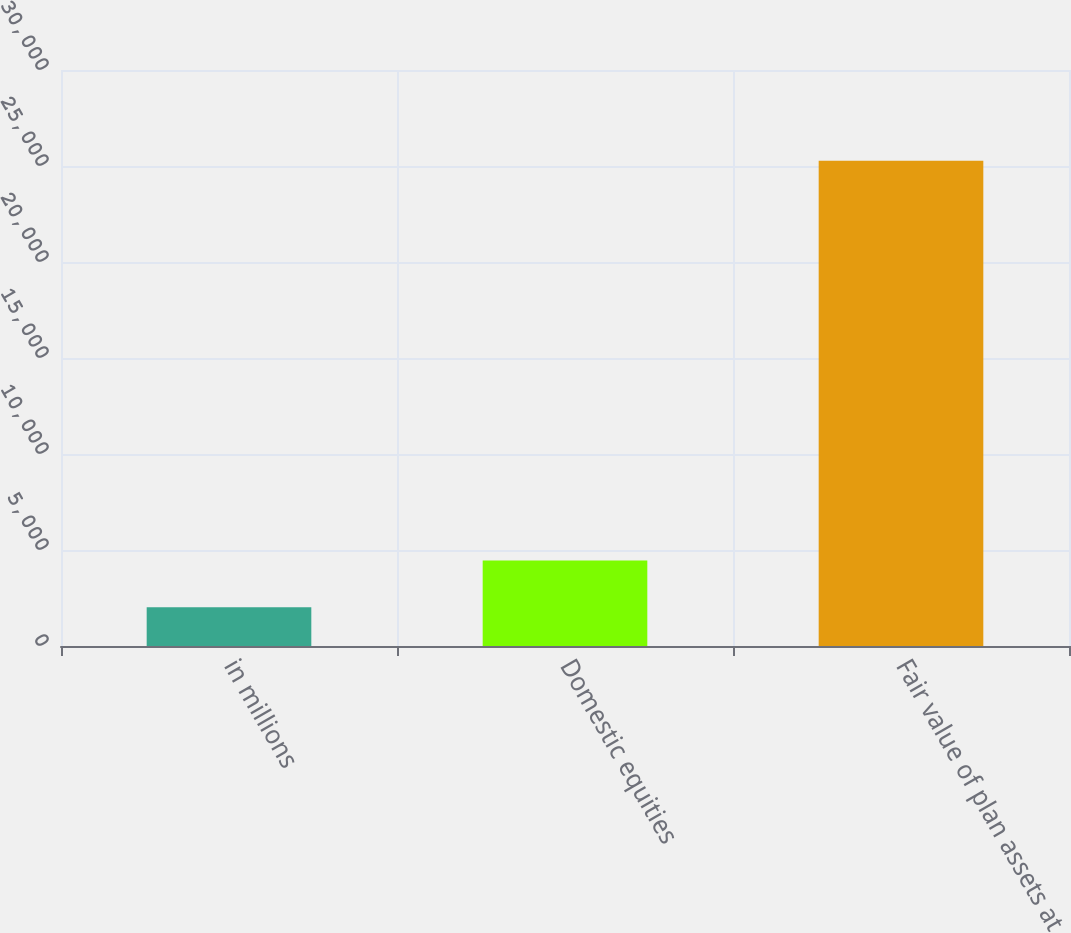<chart> <loc_0><loc_0><loc_500><loc_500><bar_chart><fcel>in millions<fcel>Domestic equities<fcel>Fair value of plan assets at<nl><fcel>2013<fcel>4452<fcel>25273<nl></chart> 